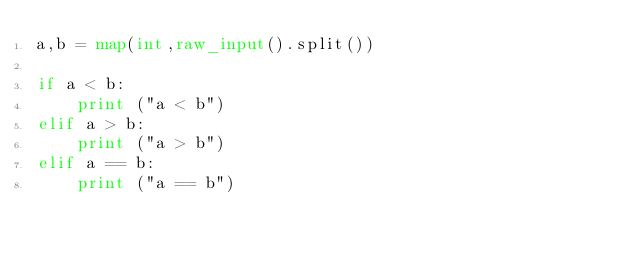<code> <loc_0><loc_0><loc_500><loc_500><_Python_>a,b = map(int,raw_input().split())

if a < b:
    print ("a < b")
elif a > b:
    print ("a > b")
elif a == b:
    print ("a == b")</code> 